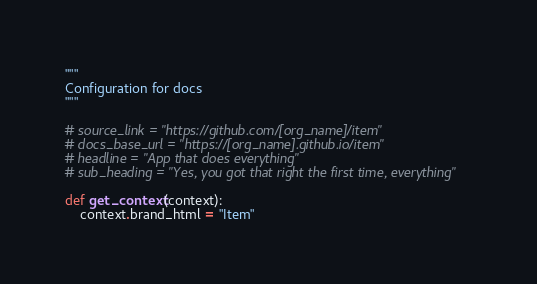Convert code to text. <code><loc_0><loc_0><loc_500><loc_500><_Python_>"""
Configuration for docs
"""

# source_link = "https://github.com/[org_name]/item"
# docs_base_url = "https://[org_name].github.io/item"
# headline = "App that does everything"
# sub_heading = "Yes, you got that right the first time, everything"

def get_context(context):
	context.brand_html = "Item"
</code> 